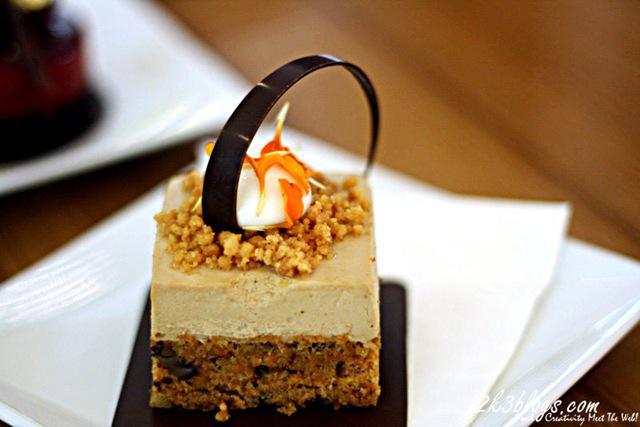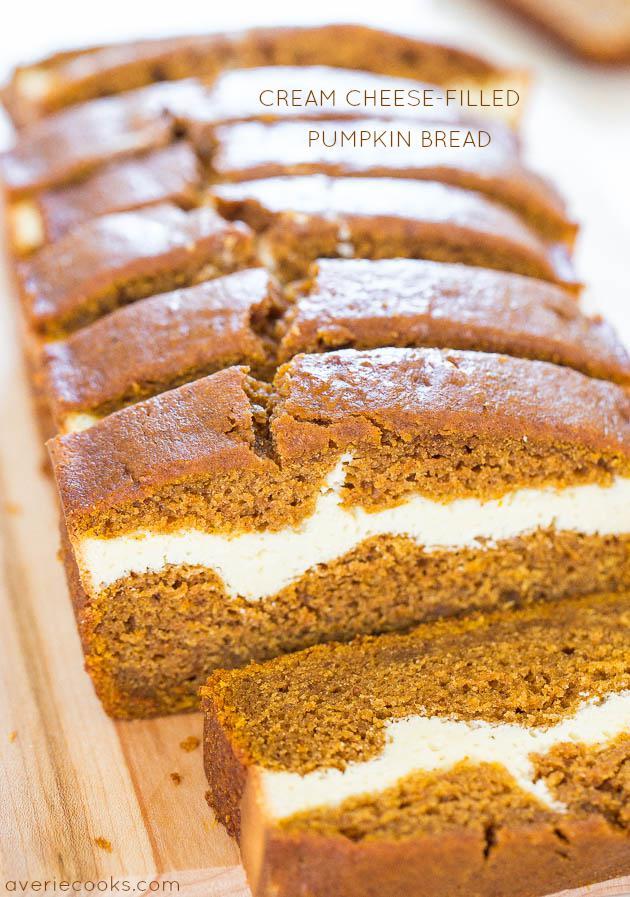The first image is the image on the left, the second image is the image on the right. Examine the images to the left and right. Is the description "A cake with multiple layers is sitting on a plate in one image, while a single serving of a different dessert in the second image." accurate? Answer yes or no. No. The first image is the image on the left, the second image is the image on the right. For the images shown, is this caption "One image shows one dessert slice with white on its top, and the other image shows a dessert on a round plate consisting of round layers alternating with creamy layers." true? Answer yes or no. No. 